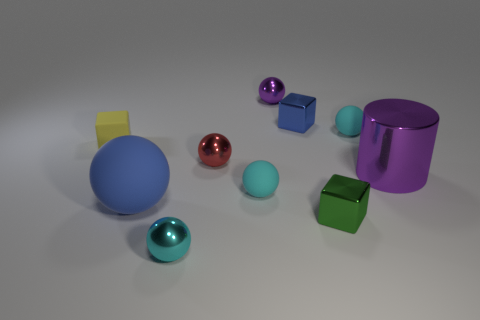Subtract all cyan spheres. How many were subtracted if there are1cyan spheres left? 2 Subtract all red cylinders. How many cyan spheres are left? 3 Subtract all tiny metal blocks. How many blocks are left? 1 Subtract all purple spheres. How many spheres are left? 5 Subtract all balls. How many objects are left? 4 Subtract all brown blocks. Subtract all red balls. How many blocks are left? 3 Add 8 big purple shiny cylinders. How many big purple shiny cylinders exist? 9 Subtract 1 red spheres. How many objects are left? 9 Subtract all big matte things. Subtract all big yellow metal spheres. How many objects are left? 9 Add 1 small cyan spheres. How many small cyan spheres are left? 4 